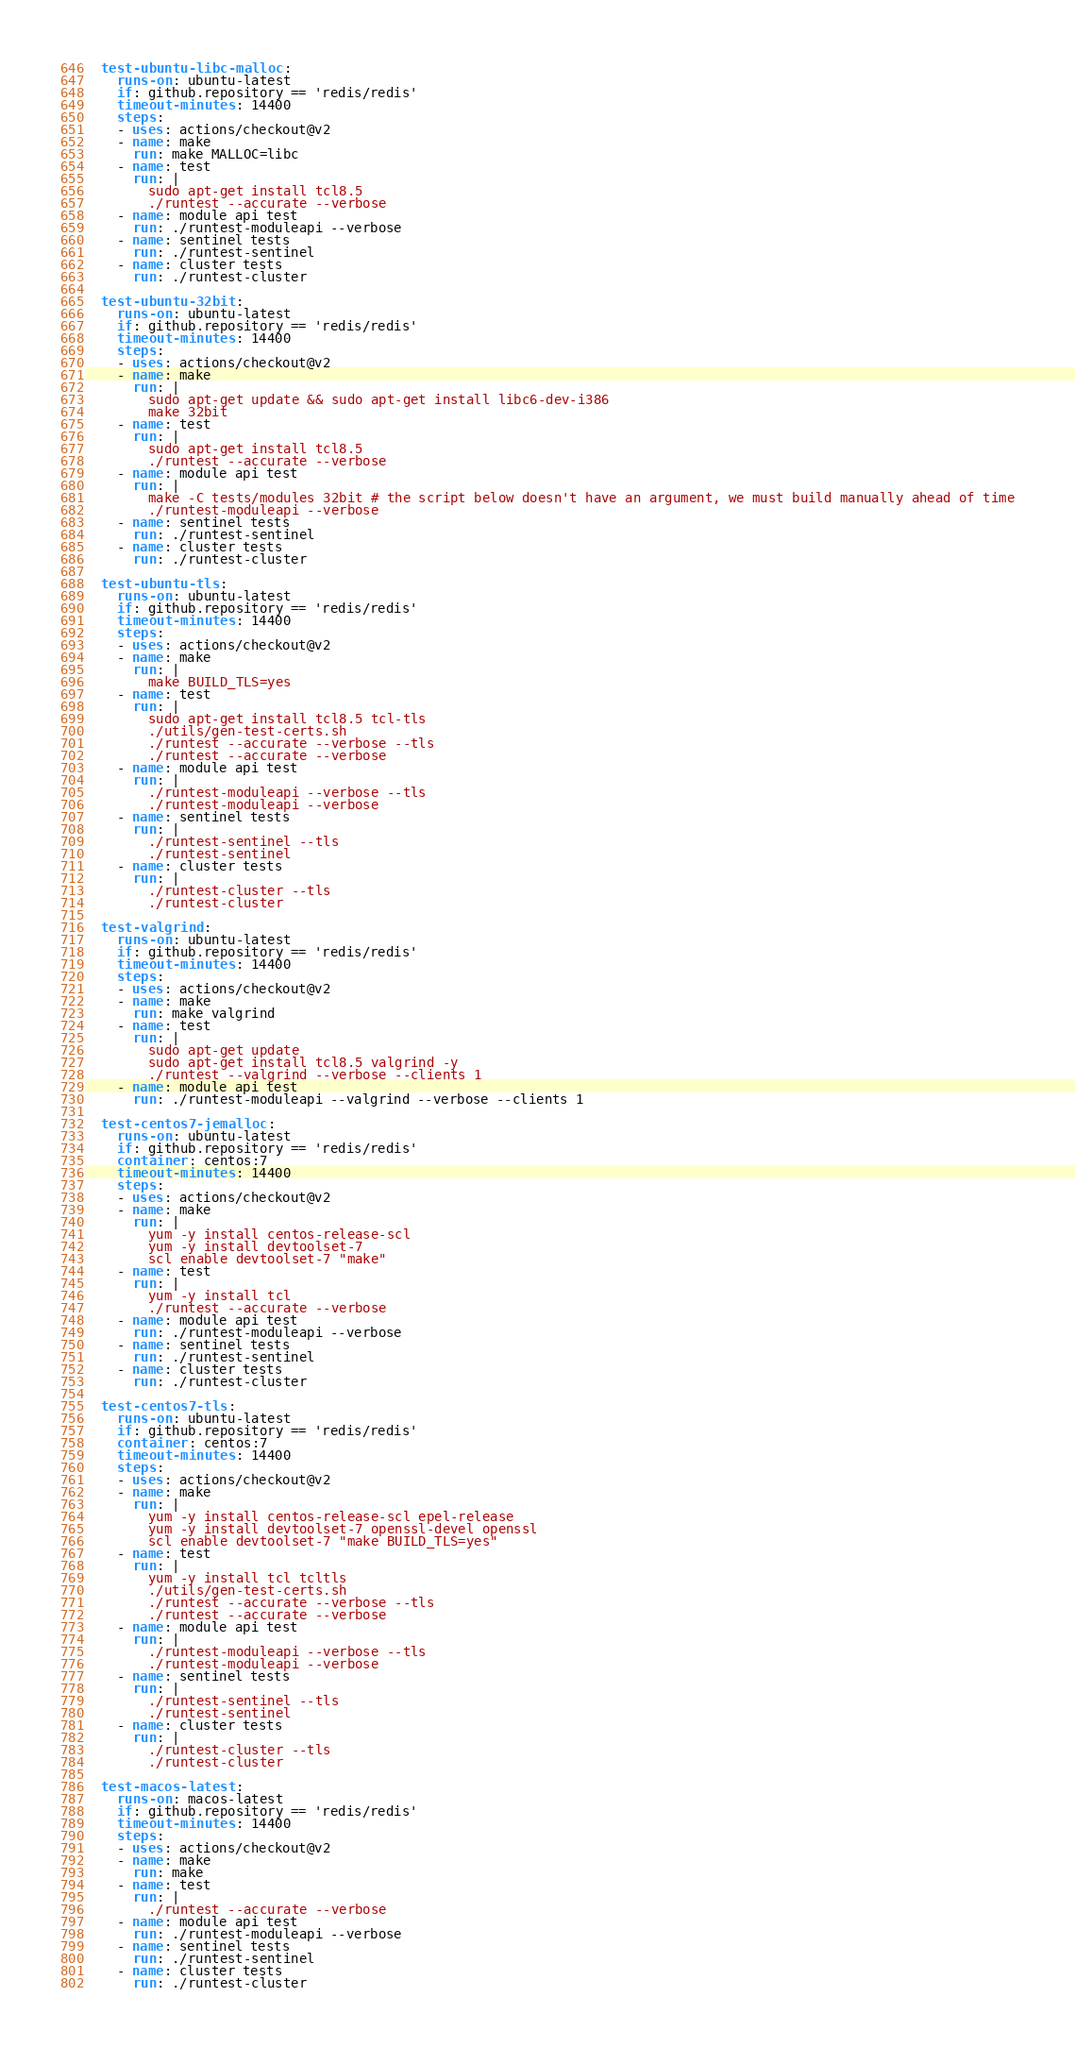<code> <loc_0><loc_0><loc_500><loc_500><_YAML_>
  test-ubuntu-libc-malloc:
    runs-on: ubuntu-latest
    if: github.repository == 'redis/redis'
    timeout-minutes: 14400
    steps:
    - uses: actions/checkout@v2
    - name: make
      run: make MALLOC=libc
    - name: test
      run: |
        sudo apt-get install tcl8.5
        ./runtest --accurate --verbose
    - name: module api test
      run: ./runtest-moduleapi --verbose
    - name: sentinel tests
      run: ./runtest-sentinel
    - name: cluster tests
      run: ./runtest-cluster

  test-ubuntu-32bit:
    runs-on: ubuntu-latest
    if: github.repository == 'redis/redis'
    timeout-minutes: 14400
    steps:
    - uses: actions/checkout@v2
    - name: make
      run: |
        sudo apt-get update && sudo apt-get install libc6-dev-i386
        make 32bit
    - name: test
      run: |
        sudo apt-get install tcl8.5
        ./runtest --accurate --verbose
    - name: module api test
      run: |
        make -C tests/modules 32bit # the script below doesn't have an argument, we must build manually ahead of time
        ./runtest-moduleapi --verbose
    - name: sentinel tests
      run: ./runtest-sentinel
    - name: cluster tests
      run: ./runtest-cluster

  test-ubuntu-tls:
    runs-on: ubuntu-latest
    if: github.repository == 'redis/redis'
    timeout-minutes: 14400
    steps:
    - uses: actions/checkout@v2
    - name: make
      run: |
        make BUILD_TLS=yes
    - name: test
      run: |
        sudo apt-get install tcl8.5 tcl-tls
        ./utils/gen-test-certs.sh
        ./runtest --accurate --verbose --tls
        ./runtest --accurate --verbose
    - name: module api test
      run: |
        ./runtest-moduleapi --verbose --tls
        ./runtest-moduleapi --verbose
    - name: sentinel tests
      run: |
        ./runtest-sentinel --tls
        ./runtest-sentinel
    - name: cluster tests
      run: |
        ./runtest-cluster --tls
        ./runtest-cluster

  test-valgrind:
    runs-on: ubuntu-latest
    if: github.repository == 'redis/redis'
    timeout-minutes: 14400
    steps:
    - uses: actions/checkout@v2
    - name: make
      run: make valgrind
    - name: test
      run: |
        sudo apt-get update
        sudo apt-get install tcl8.5 valgrind -y
        ./runtest --valgrind --verbose --clients 1
    - name: module api test
      run: ./runtest-moduleapi --valgrind --verbose --clients 1

  test-centos7-jemalloc:
    runs-on: ubuntu-latest
    if: github.repository == 'redis/redis'
    container: centos:7
    timeout-minutes: 14400
    steps:
    - uses: actions/checkout@v2
    - name: make
      run: |
        yum -y install centos-release-scl
        yum -y install devtoolset-7
        scl enable devtoolset-7 "make"
    - name: test
      run: |
        yum -y install tcl
        ./runtest --accurate --verbose
    - name: module api test
      run: ./runtest-moduleapi --verbose
    - name: sentinel tests
      run: ./runtest-sentinel
    - name: cluster tests
      run: ./runtest-cluster

  test-centos7-tls:
    runs-on: ubuntu-latest
    if: github.repository == 'redis/redis'
    container: centos:7
    timeout-minutes: 14400
    steps:
    - uses: actions/checkout@v2
    - name: make
      run: |
        yum -y install centos-release-scl epel-release
        yum -y install devtoolset-7 openssl-devel openssl
        scl enable devtoolset-7 "make BUILD_TLS=yes"
    - name: test
      run: |
        yum -y install tcl tcltls
        ./utils/gen-test-certs.sh
        ./runtest --accurate --verbose --tls
        ./runtest --accurate --verbose
    - name: module api test
      run: |
        ./runtest-moduleapi --verbose --tls
        ./runtest-moduleapi --verbose
    - name: sentinel tests
      run: |
        ./runtest-sentinel --tls
        ./runtest-sentinel
    - name: cluster tests
      run: |
        ./runtest-cluster --tls
        ./runtest-cluster

  test-macos-latest:
    runs-on: macos-latest
    if: github.repository == 'redis/redis'
    timeout-minutes: 14400
    steps:
    - uses: actions/checkout@v2
    - name: make
      run: make
    - name: test
      run: |
        ./runtest --accurate --verbose
    - name: module api test
      run: ./runtest-moduleapi --verbose
    - name: sentinel tests
      run: ./runtest-sentinel
    - name: cluster tests
      run: ./runtest-cluster

</code> 